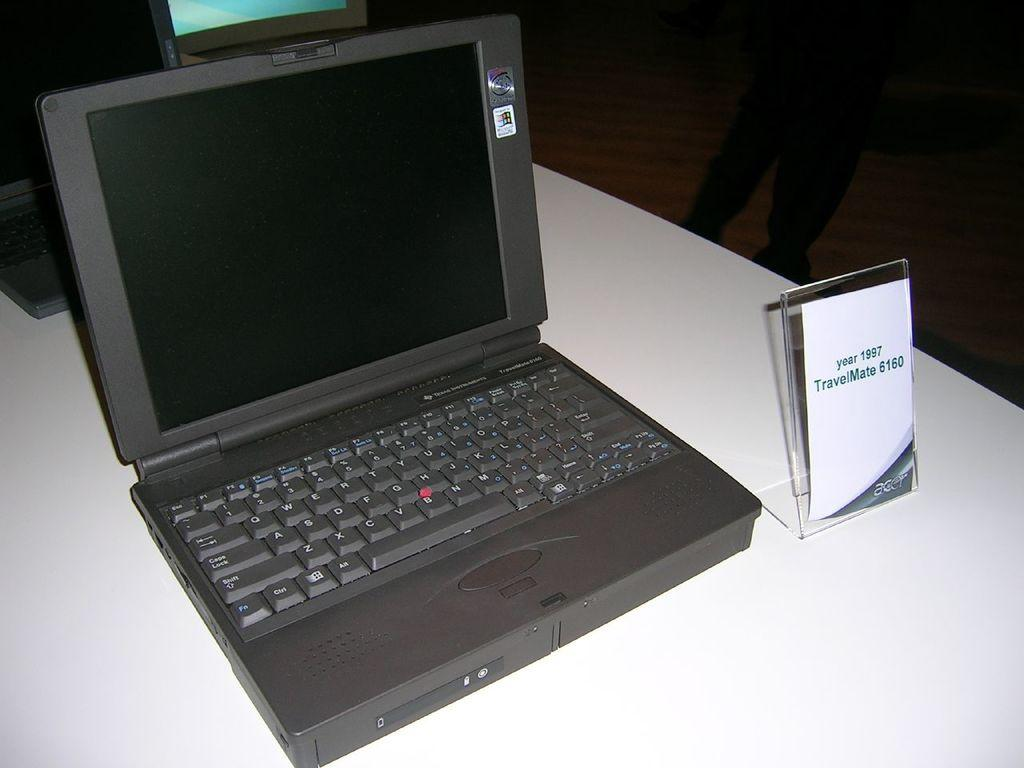Provide a one-sentence caption for the provided image. The old laptop shown here is from the year 1997. 